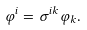Convert formula to latex. <formula><loc_0><loc_0><loc_500><loc_500>\varphi ^ { i } = \sigma ^ { i k } \varphi _ { k } .</formula> 